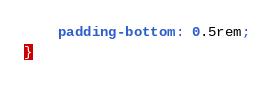Convert code to text. <code><loc_0><loc_0><loc_500><loc_500><_CSS_>	padding-bottom: 0.5rem;
}
</code> 